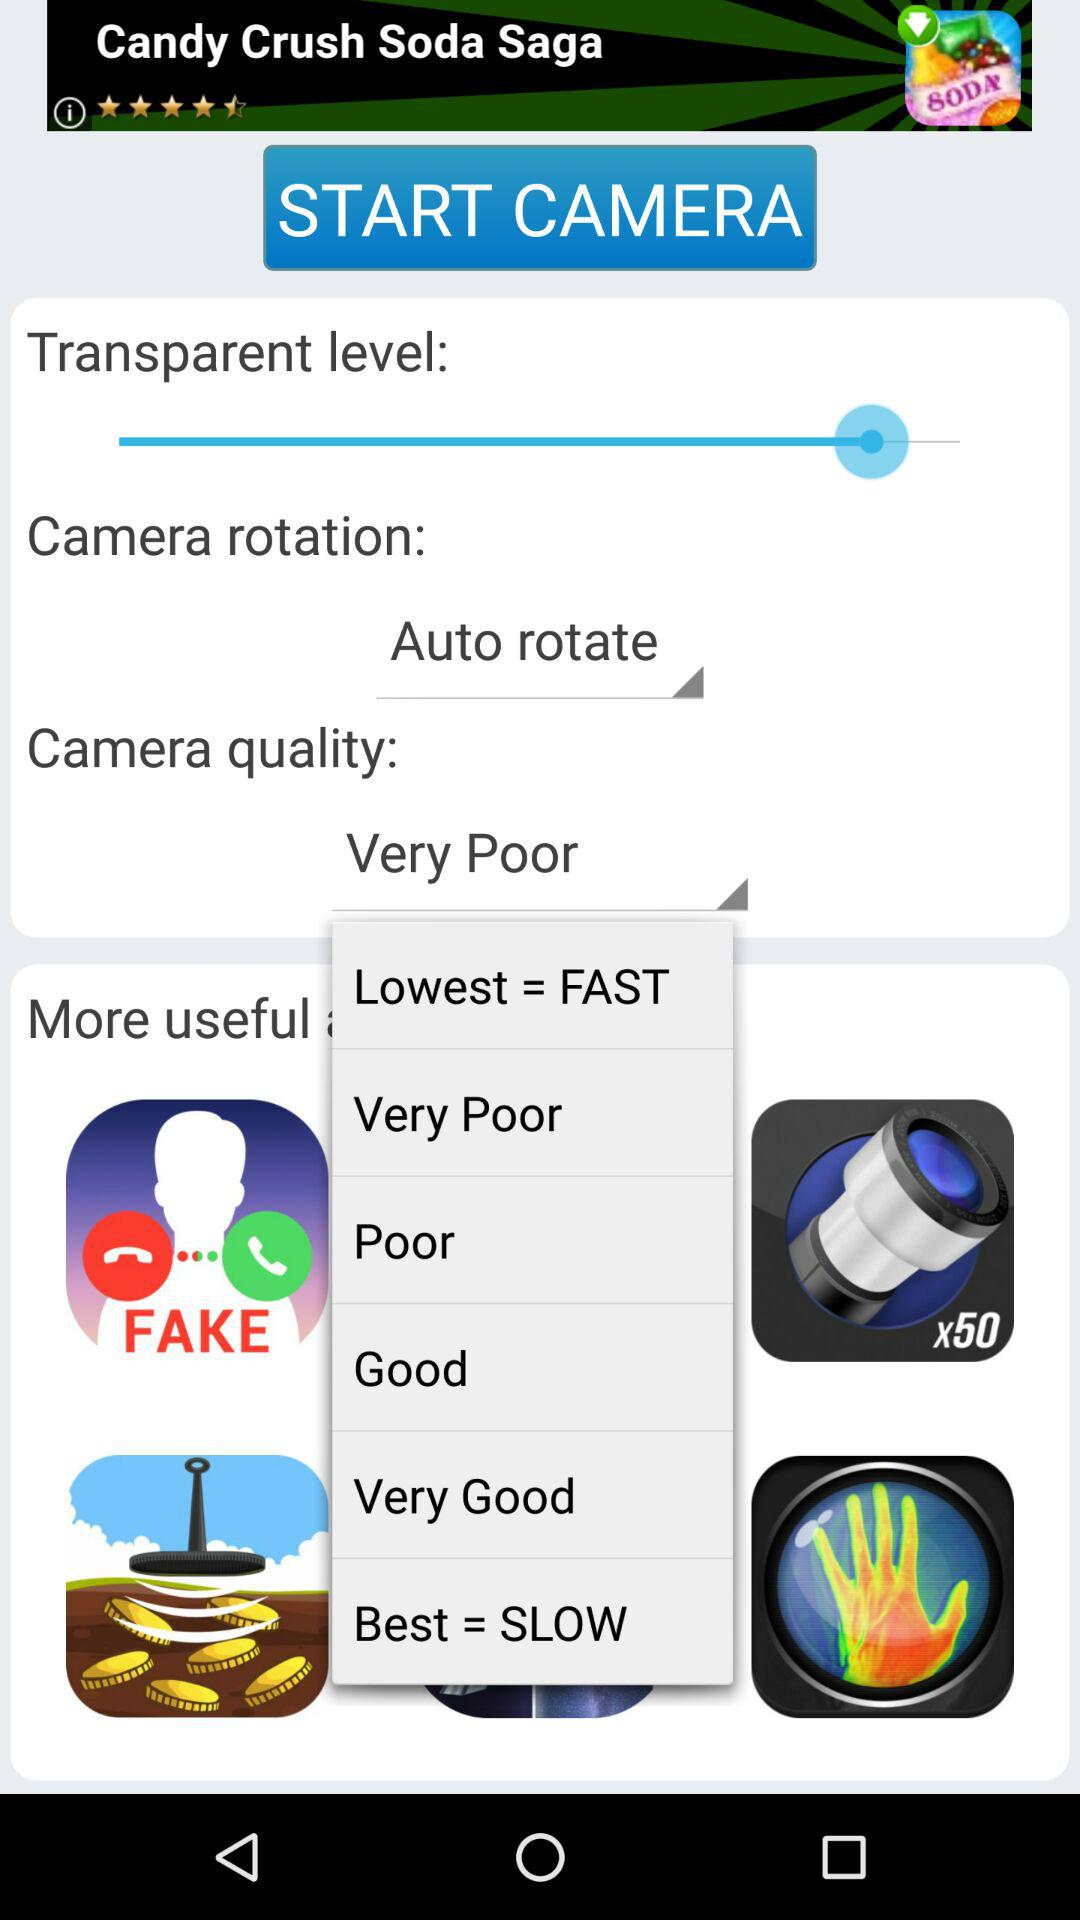What is the camera quality? The camera quality is very poor. 